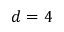Convert formula to latex. <formula><loc_0><loc_0><loc_500><loc_500>d = 4</formula> 